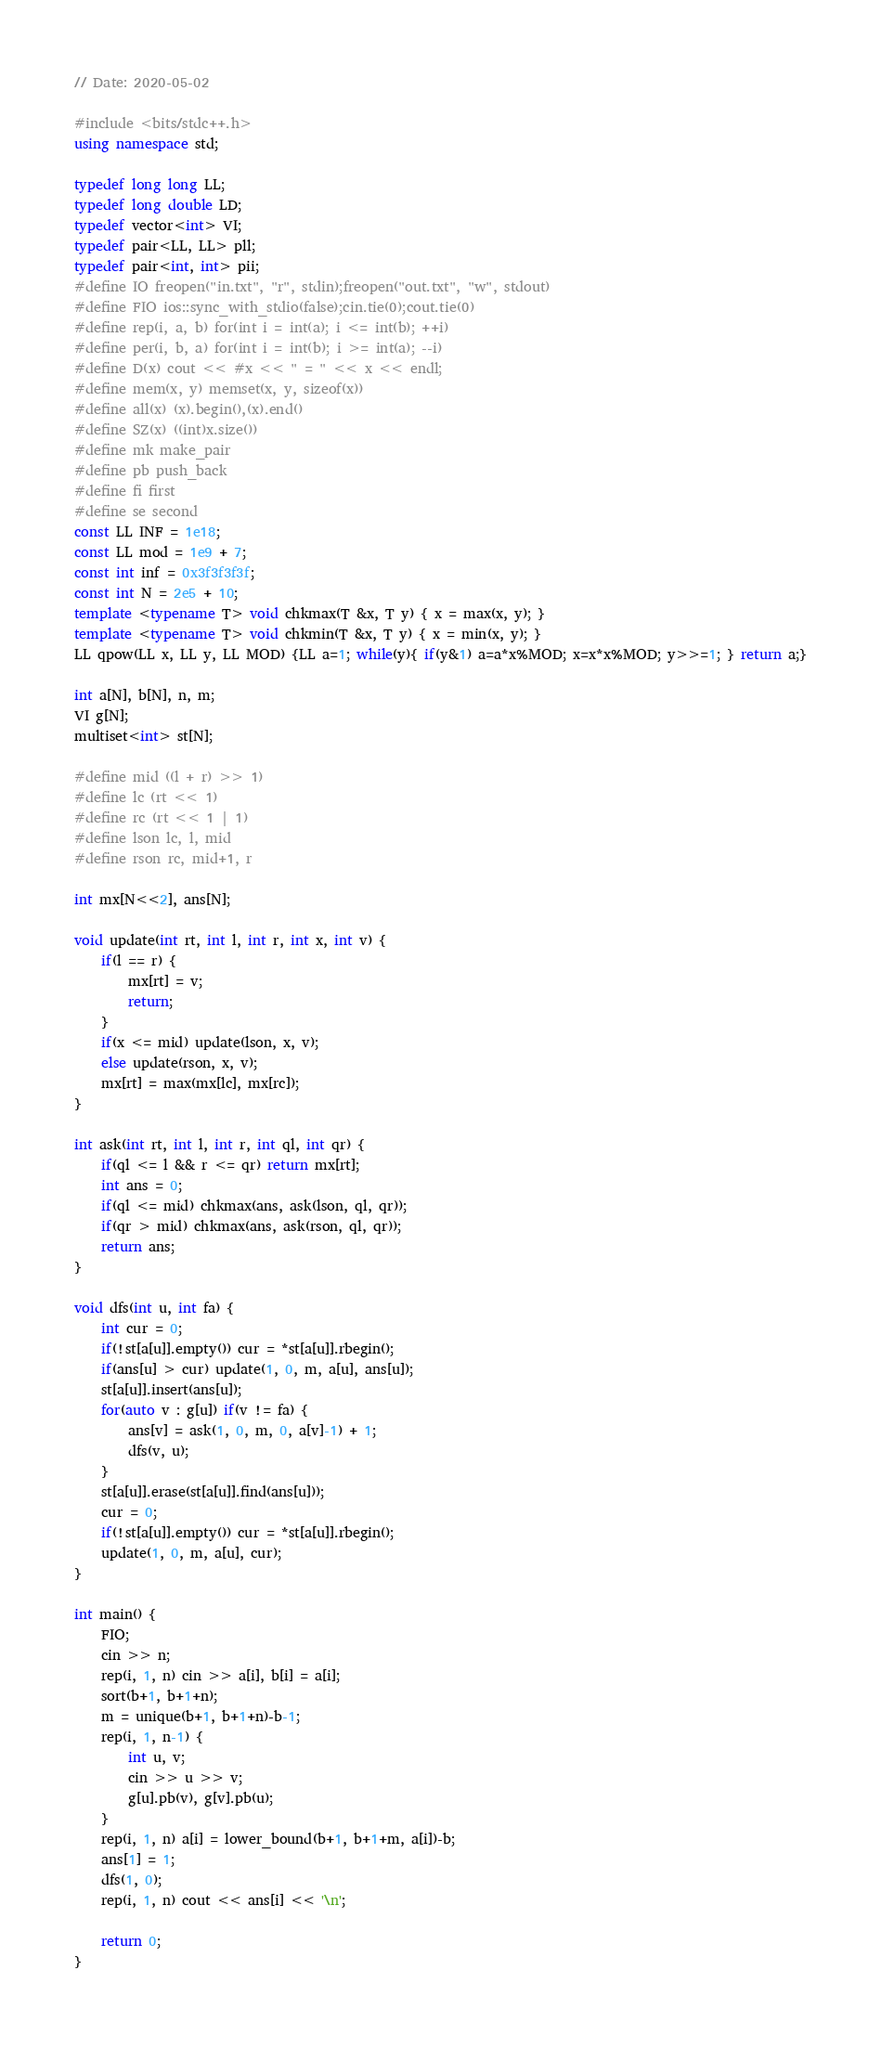Convert code to text. <code><loc_0><loc_0><loc_500><loc_500><_C++_>// Date: 2020-05-02

#include <bits/stdc++.h>
using namespace std;

typedef long long LL;
typedef long double LD;
typedef vector<int> VI;
typedef pair<LL, LL> pll;
typedef pair<int, int> pii;
#define IO freopen("in.txt", "r", stdin);freopen("out.txt", "w", stdout)
#define FIO ios::sync_with_stdio(false);cin.tie(0);cout.tie(0)
#define rep(i, a, b) for(int i = int(a); i <= int(b); ++i)
#define per(i, b, a) for(int i = int(b); i >= int(a); --i)
#define D(x) cout << #x << " = " << x << endl;
#define mem(x, y) memset(x, y, sizeof(x))
#define all(x) (x).begin(),(x).end()
#define SZ(x) ((int)x.size())
#define mk make_pair
#define pb push_back
#define fi first
#define se second
const LL INF = 1e18;
const LL mod = 1e9 + 7;
const int inf = 0x3f3f3f3f;
const int N = 2e5 + 10;
template <typename T> void chkmax(T &x, T y) { x = max(x, y); }
template <typename T> void chkmin(T &x, T y) { x = min(x, y); }
LL qpow(LL x, LL y, LL MOD) {LL a=1; while(y){ if(y&1) a=a*x%MOD; x=x*x%MOD; y>>=1; } return a;}

int a[N], b[N], n, m;
VI g[N];
multiset<int> st[N];

#define mid ((l + r) >> 1)
#define lc (rt << 1)
#define rc (rt << 1 | 1)
#define lson lc, l, mid
#define rson rc, mid+1, r

int mx[N<<2], ans[N];

void update(int rt, int l, int r, int x, int v) {
    if(l == r) {
        mx[rt] = v;
        return;
    }
    if(x <= mid) update(lson, x, v);
    else update(rson, x, v);
    mx[rt] = max(mx[lc], mx[rc]);
}

int ask(int rt, int l, int r, int ql, int qr) {
    if(ql <= l && r <= qr) return mx[rt];
    int ans = 0;
    if(ql <= mid) chkmax(ans, ask(lson, ql, qr));
    if(qr > mid) chkmax(ans, ask(rson, ql, qr));
    return ans;
}

void dfs(int u, int fa) {
    int cur = 0;
    if(!st[a[u]].empty()) cur = *st[a[u]].rbegin();
    if(ans[u] > cur) update(1, 0, m, a[u], ans[u]);
    st[a[u]].insert(ans[u]);
    for(auto v : g[u]) if(v != fa) {
        ans[v] = ask(1, 0, m, 0, a[v]-1) + 1;
        dfs(v, u);
    }
    st[a[u]].erase(st[a[u]].find(ans[u]));
    cur = 0;
    if(!st[a[u]].empty()) cur = *st[a[u]].rbegin();
    update(1, 0, m, a[u], cur);
}

int main() {
    FIO;
    cin >> n;
    rep(i, 1, n) cin >> a[i], b[i] = a[i];
    sort(b+1, b+1+n);
    m = unique(b+1, b+1+n)-b-1;
    rep(i, 1, n-1) {
        int u, v;
        cin >> u >> v;
        g[u].pb(v), g[v].pb(u);
    }
    rep(i, 1, n) a[i] = lower_bound(b+1, b+1+m, a[i])-b;
    ans[1] = 1;
    dfs(1, 0);
    rep(i, 1, n) cout << ans[i] << '\n';

    return 0;
}</code> 